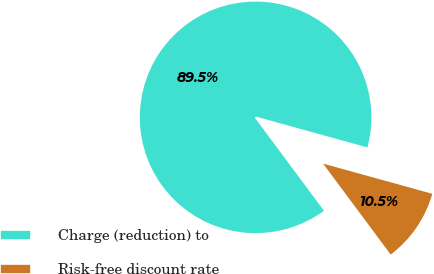Convert chart. <chart><loc_0><loc_0><loc_500><loc_500><pie_chart><fcel>Charge (reduction) to<fcel>Risk-free discount rate<nl><fcel>89.47%<fcel>10.53%<nl></chart> 